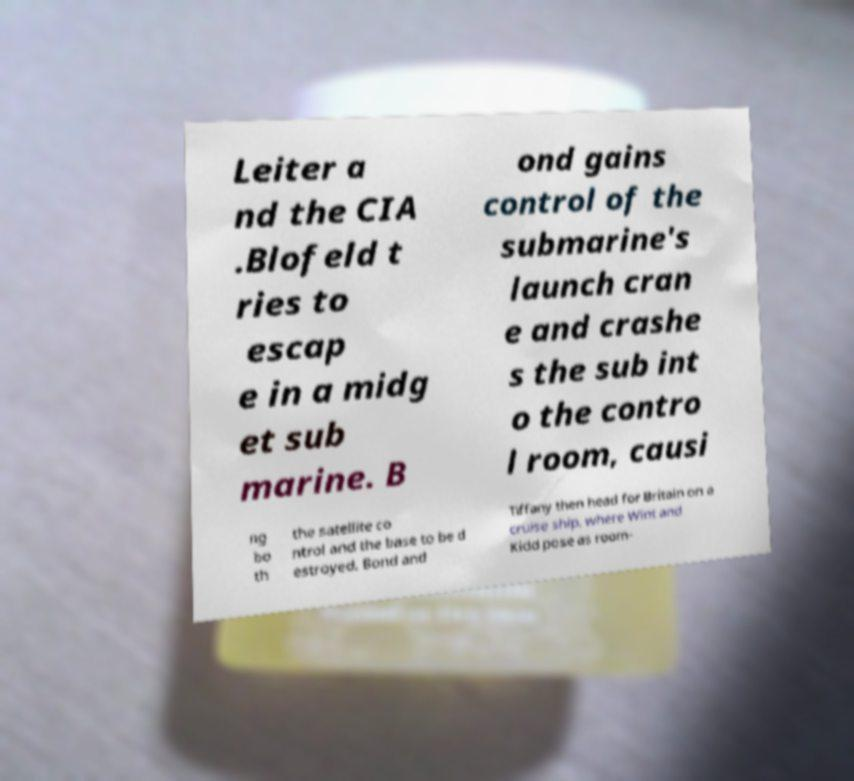What messages or text are displayed in this image? I need them in a readable, typed format. Leiter a nd the CIA .Blofeld t ries to escap e in a midg et sub marine. B ond gains control of the submarine's launch cran e and crashe s the sub int o the contro l room, causi ng bo th the satellite co ntrol and the base to be d estroyed. Bond and Tiffany then head for Britain on a cruise ship, where Wint and Kidd pose as room- 